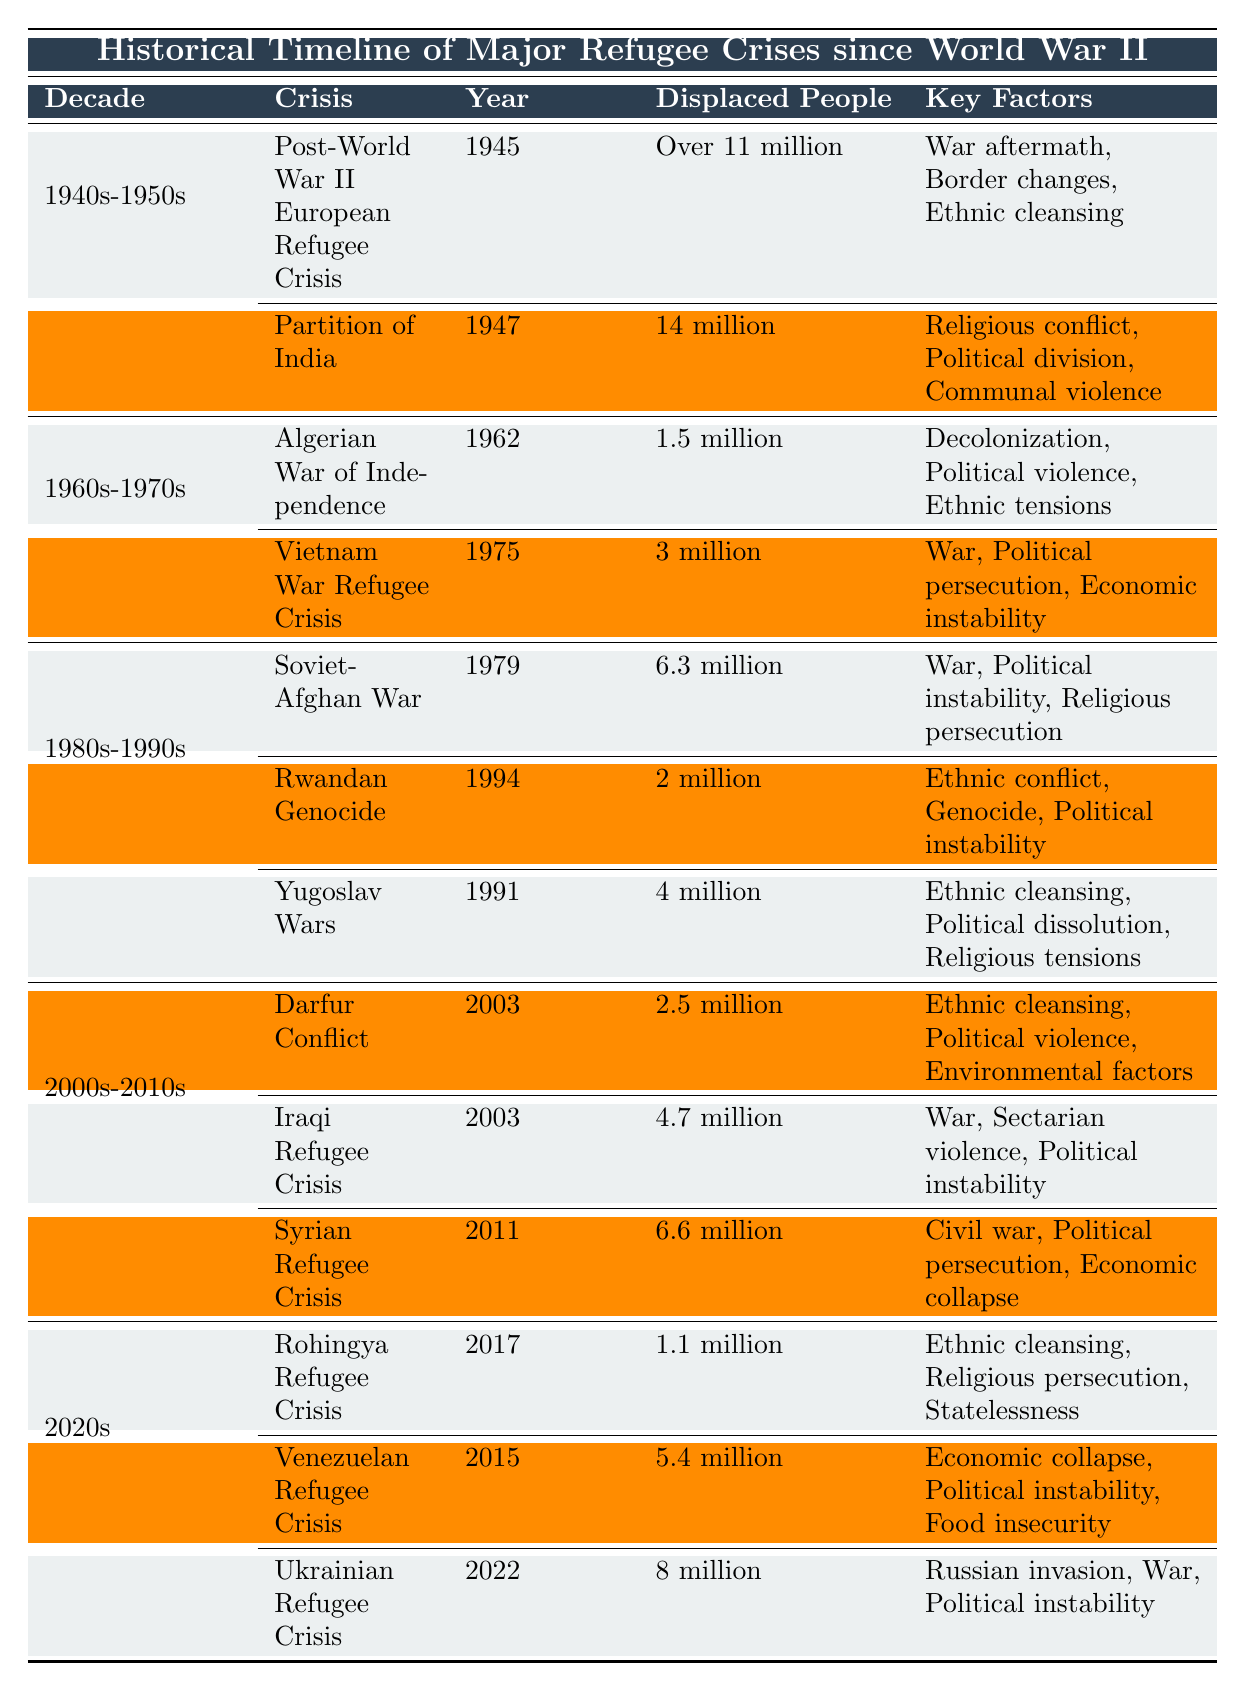What was the largest refugee crisis in the 1940s-1950s? The table shows that the Post-World War II European Refugee Crisis in 1945 had over 11 million displaced people, which is the highest figure in that decade.
Answer: Over 11 million Which decade had the highest number of displaced people due to refugee crises? To find the decade with the most displaced people, we compare the largest figures in each decade: 11 million (1940s-1950s), 6.3 million (1980s-1990s), 6.6 million (2000s-2010s), and 8 million (2020s). The 1940s-1950s had the highest total since it contains the crisis with over 11 million.
Answer: 1940s-1950s How many displaced people were involved in the Algerian War of Independence? The table directly states that the Algerian War of Independence in 1962 resulted in 1.5 million displaced people.
Answer: 1.5 million True or false: The Syrian Refugee Crisis had more displaced people than the Venezuelan Refugee Crisis. The Syrian Refugee Crisis in 2011 had 6.6 million displaced people, while the Venezuelan Refugee Crisis in 2015 had 5.4 million displaced people. Therefore, the statement is true.
Answer: True What is the total number of displaced people across all crises listed in the 2000s-2010s? The total is calculated by adding the figures: 2.5 million (Darfur) + 4.7 million (Iraq) + 6.6 million (Syria) = 13.8 million.
Answer: 13.8 million Which crisis caused the least displacement in the 1980s-1990s? Among the crises listed in that decade, the Rwandan Genocide in 1994 resulted in 2 million displaced people, which is less than the 6.3 million from the Soviet-Afghan War and 4 million from the Yugoslav Wars.
Answer: 2 million In how many crises did more than 5 million people get displaced? The crises with over 5 million displaced people are the Post-World War II European Refugee Crisis (over 11 million), Yugoslav Wars (4 million), Syrian Refugee Crisis (6.6 million), Iraqi Refugee Crisis (4.7 million), and Ukrainian Refugee Crisis (8 million). Counting these yields 4 crises.
Answer: 4 What were the key factors leading to the Venezuelan Refugee Crisis? The table specifies the key factors as economic collapse, political instability, and food insecurity.
Answer: Economic collapse, political instability, food insecurity Which crisis occurred closest to the 2020s? The Ukrainian Refugee Crisis in 2022 occurred in the 2020s as shown in the table and is the most recent crisis listed.
Answer: Ukrainian Refugee Crisis What decade had crises primarily driven by ethnic factors? The 1980s-1990s had crises like the Rwandan Genocide and Yugoslav Wars, which were driven by ethnic conflict and cleansing.
Answer: 1980s-1990s 